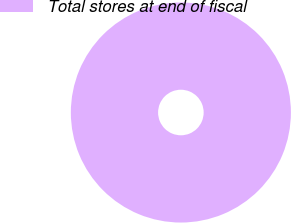Convert chart. <chart><loc_0><loc_0><loc_500><loc_500><pie_chart><fcel>Total stores at end of fiscal<nl><fcel>100.0%<nl></chart> 